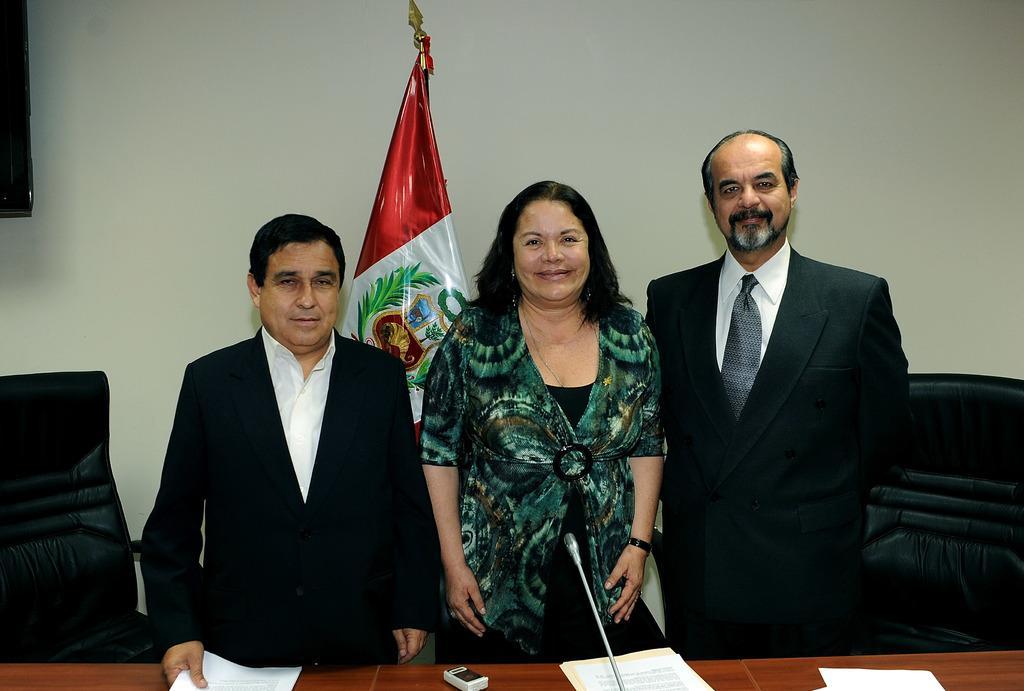In one or two sentences, can you explain what this image depicts? It is a meeting room there is a brown color table on which some papers are placed there are three people standing in front of table a woman is standing in the middle and two men on the either side there is a chair beside them in the background there is a flag and a wall. 